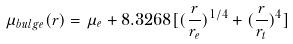<formula> <loc_0><loc_0><loc_500><loc_500>\mu _ { b u l g e } ( r ) = \mu _ { e } + 8 . 3 2 6 8 [ ( \frac { r } { r _ { e } } ) ^ { 1 / 4 } + ( \frac { r } { r _ { t } } ) ^ { 4 } ]</formula> 